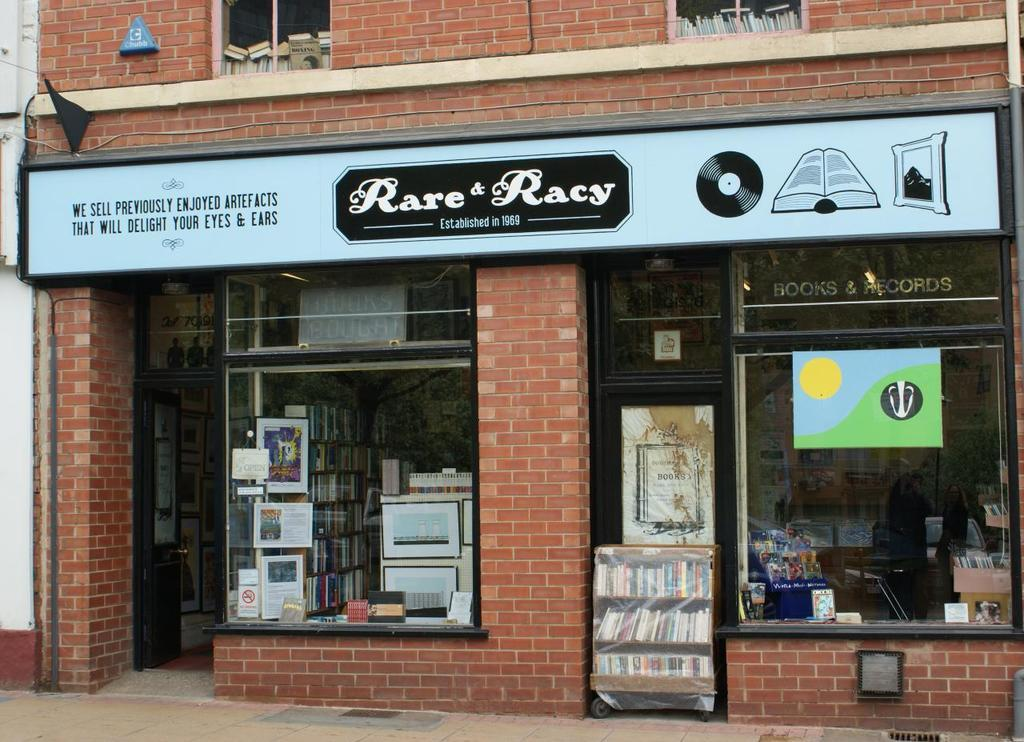Provide a one-sentence caption for the provided image. A bookcase is sitting outside of a store called Rare and Racy. 